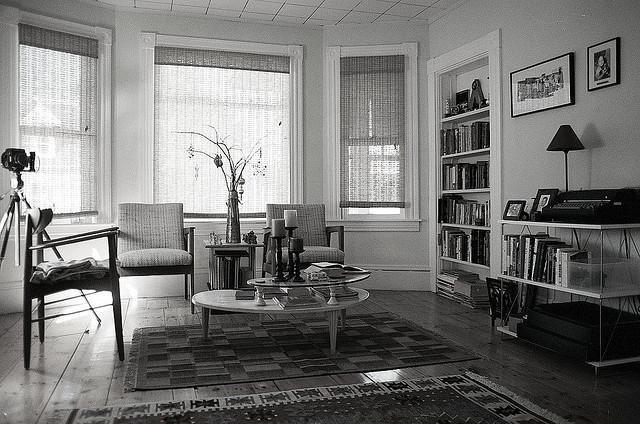What is the camera on the left setup on? tripod 